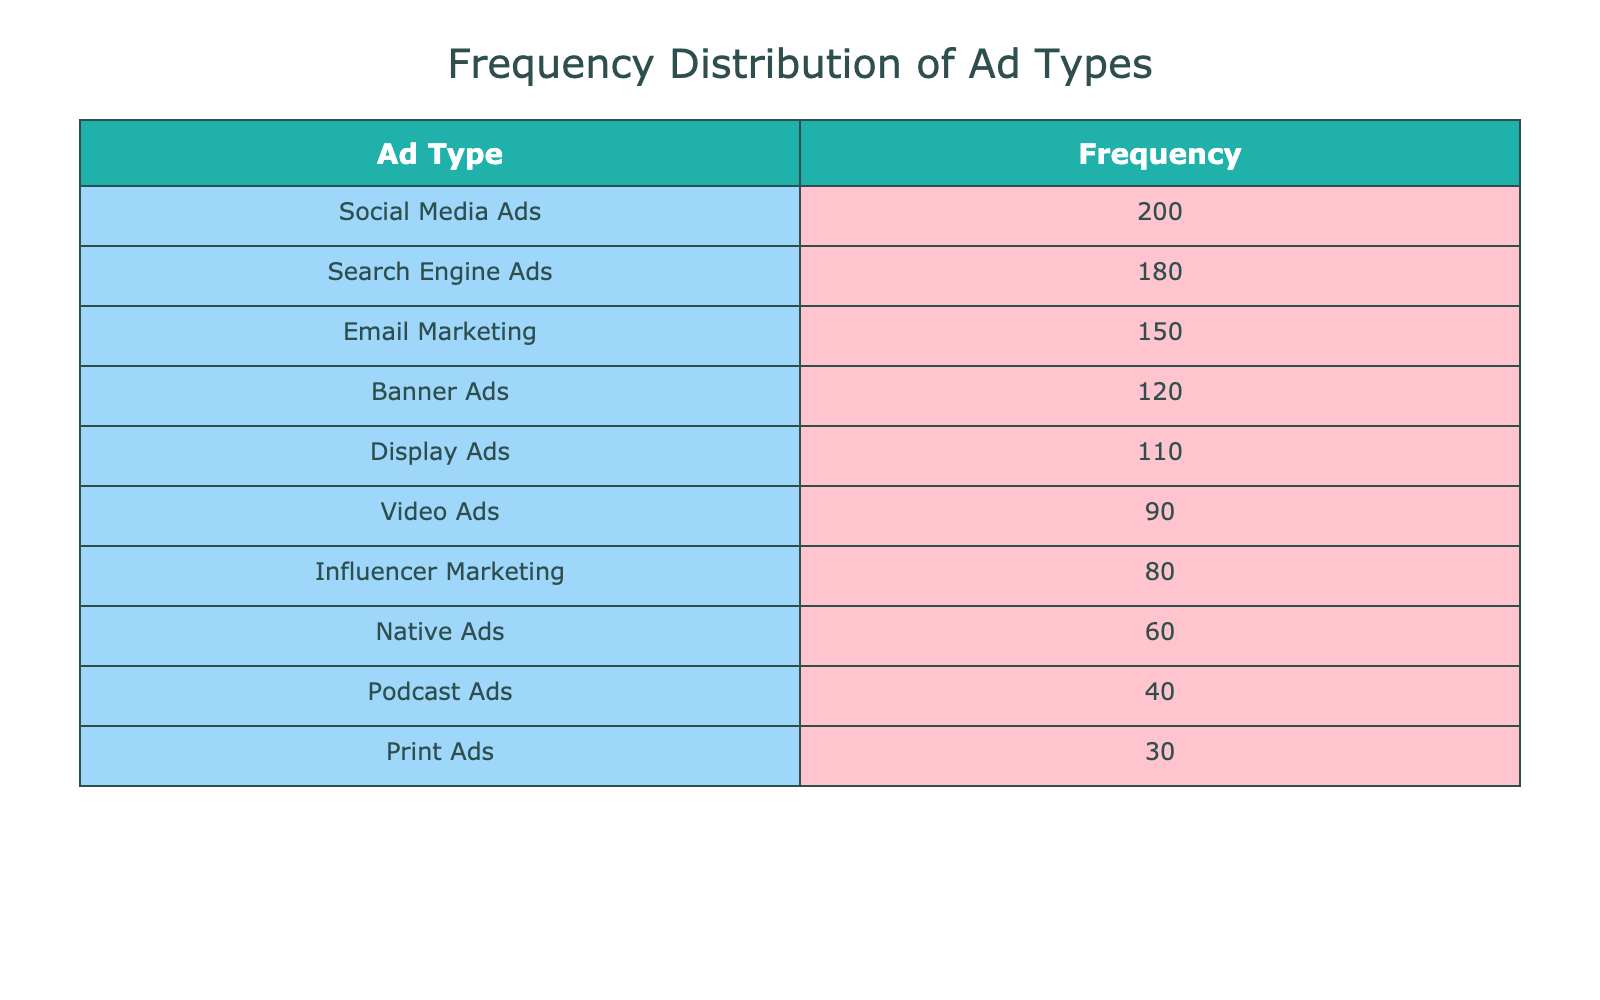What is the frequency of Social Media Ads? The table lists the frequency of different ad types, and Social Media Ads are directly mentioned in it with a frequency of 200.
Answer: 200 Which ad type has the highest frequency? By looking at the sorted table, Social Media Ads have the highest frequency value at 200.
Answer: Social Media Ads What is the total frequency of Video Ads and Influencer Marketing combined? The frequency of Video Ads is 90 and Influencer Marketing is 80. Combine these frequencies: 90 + 80 = 170.
Answer: 170 Is Email Marketing used more frequently than Podcast Ads? Email Marketing has a frequency of 150, while Podcast Ads have a frequency of 40; since 150 is greater than 40, the answer is yes.
Answer: Yes What is the difference in frequency between Search Engine Ads and Banner Ads? The frequency of Search Engine Ads is 180, and the frequency of Banner Ads is 120. Subtract 120 from 180: 180 - 120 = 60.
Answer: 60 What is the average frequency of the top three ad types? The top three ad types by frequency are Social Media Ads (200), Search Engine Ads (180), and Email Marketing (150). The sum is 200 + 180 + 150 = 530, and there are 3 ad types; hence the average is 530 / 3 = 176.67.
Answer: 176.67 Are there more types of ads that have a frequency higher than 100 than those with a frequency of 50 or lower? The ad types with frequency higher than 100 are: Social Media Ads (200), Search Engine Ads (180), Email Marketing (150), Banner Ads (120), and Display Ads (110) which totals 5. The types with frequency 50 or lower are: Native Ads (60) and Podcast Ads (40) totaling 2. So, there are more ad types above 100.
Answer: Yes Which ad type is the least frequently used? Analyzing the table, Print Ads show the lowest frequency, which is 30.
Answer: Print Ads What is the combined frequency of Native Ads and Print Ads? Native Ads have a frequency of 60 and Print Ads a frequency of 30. Combined, this totals 60 + 30 = 90.
Answer: 90 How many ad types have a frequency greater than 100? The table lists Social Media Ads, Search Engine Ads, Email Marketing, Banner Ads, and Display Ads, making a total of 5 ad types with frequency greater than 100.
Answer: 5 